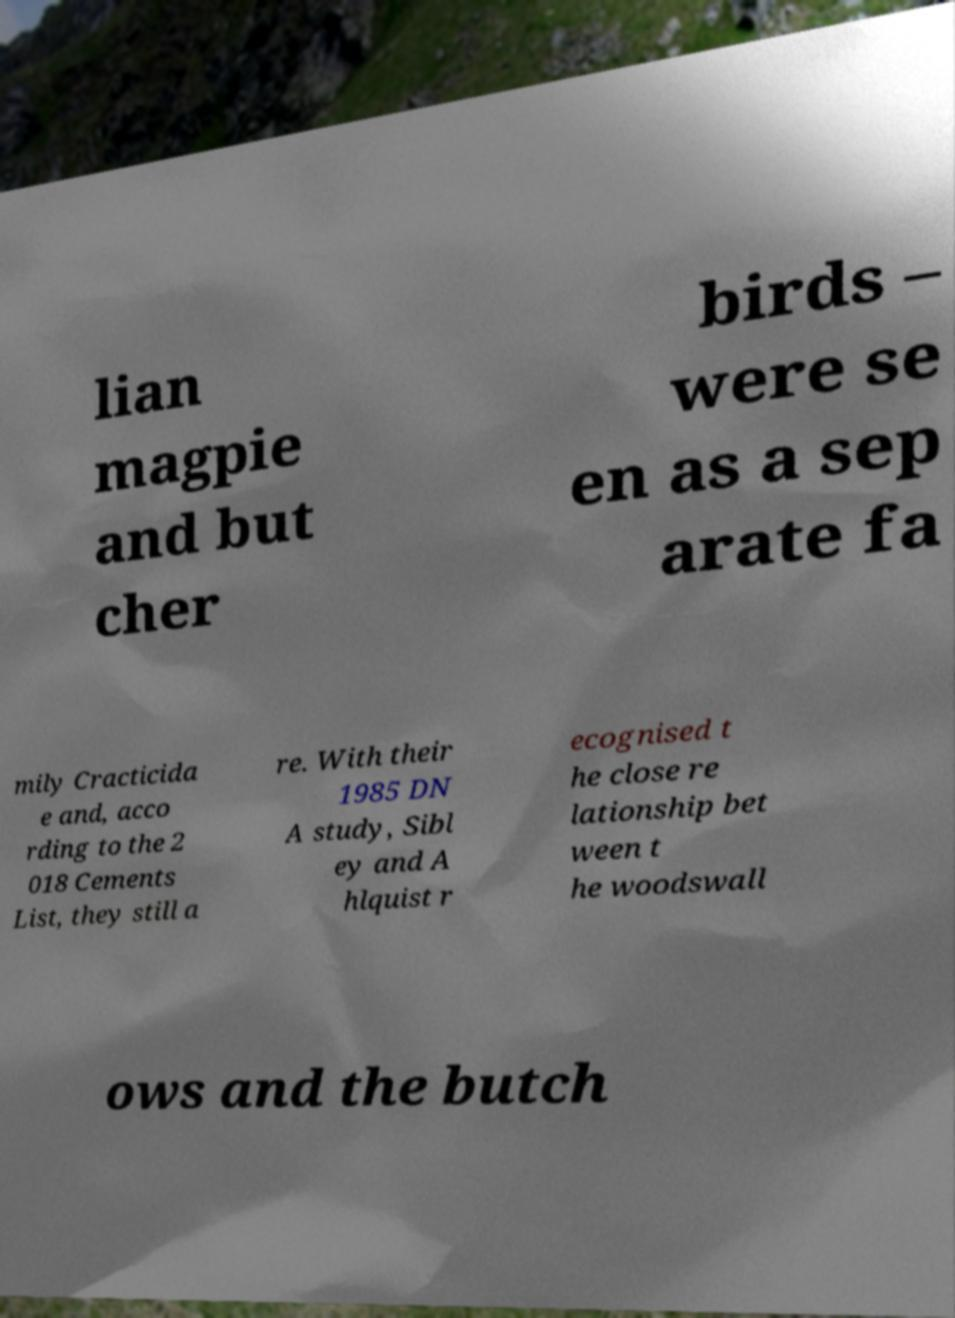Please read and relay the text visible in this image. What does it say? lian magpie and but cher birds – were se en as a sep arate fa mily Cracticida e and, acco rding to the 2 018 Cements List, they still a re. With their 1985 DN A study, Sibl ey and A hlquist r ecognised t he close re lationship bet ween t he woodswall ows and the butch 